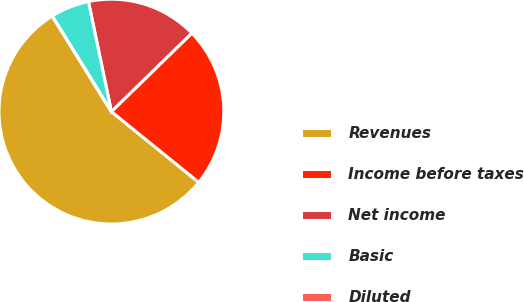Convert chart. <chart><loc_0><loc_0><loc_500><loc_500><pie_chart><fcel>Revenues<fcel>Income before taxes<fcel>Net income<fcel>Basic<fcel>Diluted<nl><fcel>55.36%<fcel>23.14%<fcel>15.97%<fcel>5.54%<fcel>0.0%<nl></chart> 